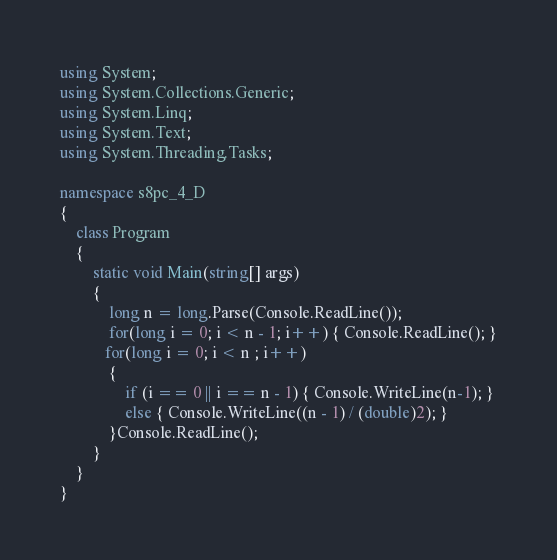<code> <loc_0><loc_0><loc_500><loc_500><_C#_>using System;
using System.Collections.Generic;
using System.Linq;
using System.Text;
using System.Threading.Tasks;

namespace s8pc_4_D
{
    class Program
    {
        static void Main(string[] args)
        {
            long n = long.Parse(Console.ReadLine());
            for(long i = 0; i < n - 1; i++) { Console.ReadLine(); }
           for(long i = 0; i < n ; i++)
            {
                if (i == 0 || i == n - 1) { Console.WriteLine(n-1); }
                else { Console.WriteLine((n - 1) / (double)2); }
            }Console.ReadLine();
        }
    }
}
</code> 